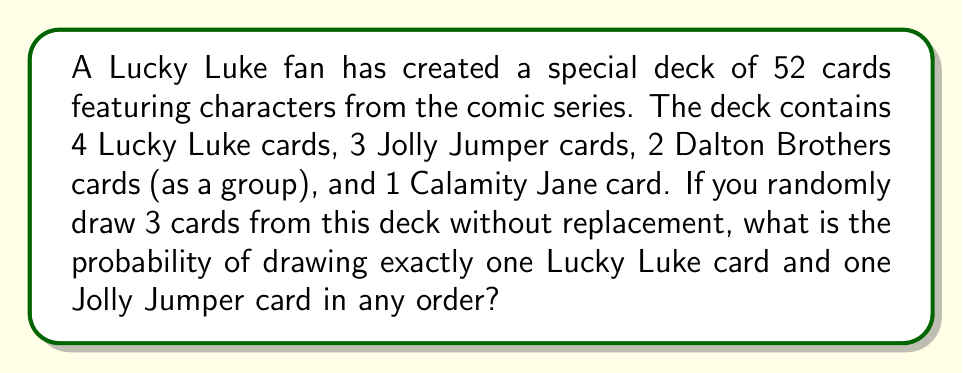Can you solve this math problem? Let's approach this step-by-step:

1) First, we need to calculate the total number of ways to draw 3 cards from 52. This is given by the combination formula:

   $$\binom{52}{3} = \frac{52!}{3!(52-3)!} = 22100$$

2) Now, we need to calculate the number of favorable outcomes. We can do this by:
   a) Choosing 1 Lucky Luke card: $\binom{4}{1}$
   b) Choosing 1 Jolly Jumper card: $\binom{3}{1}$
   c) Choosing 1 card from the remaining 45 cards: $\binom{45}{1}$

3) Multiply these together and account for the order (3! ways to arrange 3 cards):

   $$4 \cdot 3 \cdot 45 \cdot 3! = 3240$$

4) The probability is then:

   $$P(\text{1 Lucky Luke, 1 Jolly Jumper, 1 other}) = \frac{3240}{22100}$$

5) Simplifying this fraction:

   $$\frac{3240}{22100} = \frac{81}{552} \approx 0.1467$$
Answer: The probability is $\frac{81}{552}$ or approximately 0.1467 (14.67%). 